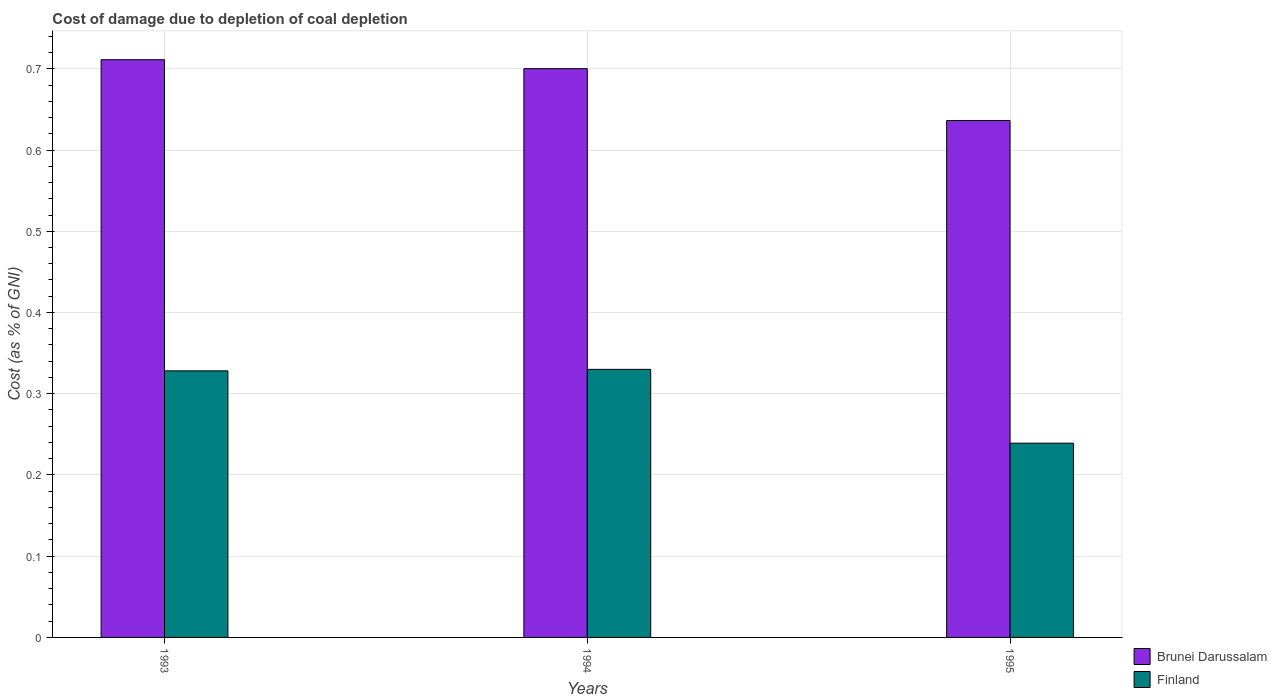How many groups of bars are there?
Ensure brevity in your answer.  3. Are the number of bars per tick equal to the number of legend labels?
Your answer should be very brief. Yes. Are the number of bars on each tick of the X-axis equal?
Provide a short and direct response. Yes. What is the label of the 1st group of bars from the left?
Give a very brief answer. 1993. In how many cases, is the number of bars for a given year not equal to the number of legend labels?
Your answer should be very brief. 0. What is the cost of damage caused due to coal depletion in Finland in 1995?
Make the answer very short. 0.24. Across all years, what is the maximum cost of damage caused due to coal depletion in Brunei Darussalam?
Offer a terse response. 0.71. Across all years, what is the minimum cost of damage caused due to coal depletion in Finland?
Keep it short and to the point. 0.24. What is the total cost of damage caused due to coal depletion in Finland in the graph?
Make the answer very short. 0.9. What is the difference between the cost of damage caused due to coal depletion in Brunei Darussalam in 1993 and that in 1994?
Offer a very short reply. 0.01. What is the difference between the cost of damage caused due to coal depletion in Finland in 1994 and the cost of damage caused due to coal depletion in Brunei Darussalam in 1995?
Your response must be concise. -0.31. What is the average cost of damage caused due to coal depletion in Finland per year?
Offer a terse response. 0.3. In the year 1995, what is the difference between the cost of damage caused due to coal depletion in Finland and cost of damage caused due to coal depletion in Brunei Darussalam?
Offer a terse response. -0.4. What is the ratio of the cost of damage caused due to coal depletion in Brunei Darussalam in 1993 to that in 1995?
Ensure brevity in your answer.  1.12. Is the cost of damage caused due to coal depletion in Brunei Darussalam in 1993 less than that in 1994?
Keep it short and to the point. No. What is the difference between the highest and the second highest cost of damage caused due to coal depletion in Brunei Darussalam?
Keep it short and to the point. 0.01. What is the difference between the highest and the lowest cost of damage caused due to coal depletion in Brunei Darussalam?
Make the answer very short. 0.07. In how many years, is the cost of damage caused due to coal depletion in Brunei Darussalam greater than the average cost of damage caused due to coal depletion in Brunei Darussalam taken over all years?
Your response must be concise. 2. Is the sum of the cost of damage caused due to coal depletion in Brunei Darussalam in 1993 and 1995 greater than the maximum cost of damage caused due to coal depletion in Finland across all years?
Give a very brief answer. Yes. How many bars are there?
Provide a succinct answer. 6. Are all the bars in the graph horizontal?
Your answer should be very brief. No. How many years are there in the graph?
Offer a terse response. 3. Where does the legend appear in the graph?
Offer a very short reply. Bottom right. How many legend labels are there?
Ensure brevity in your answer.  2. What is the title of the graph?
Provide a succinct answer. Cost of damage due to depletion of coal depletion. Does "Curacao" appear as one of the legend labels in the graph?
Your response must be concise. No. What is the label or title of the Y-axis?
Ensure brevity in your answer.  Cost (as % of GNI). What is the Cost (as % of GNI) in Brunei Darussalam in 1993?
Provide a short and direct response. 0.71. What is the Cost (as % of GNI) of Finland in 1993?
Keep it short and to the point. 0.33. What is the Cost (as % of GNI) of Brunei Darussalam in 1994?
Make the answer very short. 0.7. What is the Cost (as % of GNI) in Finland in 1994?
Provide a succinct answer. 0.33. What is the Cost (as % of GNI) of Brunei Darussalam in 1995?
Give a very brief answer. 0.64. What is the Cost (as % of GNI) in Finland in 1995?
Your response must be concise. 0.24. Across all years, what is the maximum Cost (as % of GNI) in Brunei Darussalam?
Offer a very short reply. 0.71. Across all years, what is the maximum Cost (as % of GNI) in Finland?
Keep it short and to the point. 0.33. Across all years, what is the minimum Cost (as % of GNI) in Brunei Darussalam?
Provide a short and direct response. 0.64. Across all years, what is the minimum Cost (as % of GNI) in Finland?
Make the answer very short. 0.24. What is the total Cost (as % of GNI) in Brunei Darussalam in the graph?
Your answer should be compact. 2.05. What is the total Cost (as % of GNI) of Finland in the graph?
Offer a terse response. 0.9. What is the difference between the Cost (as % of GNI) in Brunei Darussalam in 1993 and that in 1994?
Give a very brief answer. 0.01. What is the difference between the Cost (as % of GNI) in Finland in 1993 and that in 1994?
Offer a terse response. -0. What is the difference between the Cost (as % of GNI) in Brunei Darussalam in 1993 and that in 1995?
Offer a terse response. 0.07. What is the difference between the Cost (as % of GNI) of Finland in 1993 and that in 1995?
Your answer should be very brief. 0.09. What is the difference between the Cost (as % of GNI) in Brunei Darussalam in 1994 and that in 1995?
Keep it short and to the point. 0.06. What is the difference between the Cost (as % of GNI) in Finland in 1994 and that in 1995?
Offer a very short reply. 0.09. What is the difference between the Cost (as % of GNI) in Brunei Darussalam in 1993 and the Cost (as % of GNI) in Finland in 1994?
Keep it short and to the point. 0.38. What is the difference between the Cost (as % of GNI) of Brunei Darussalam in 1993 and the Cost (as % of GNI) of Finland in 1995?
Offer a terse response. 0.47. What is the difference between the Cost (as % of GNI) in Brunei Darussalam in 1994 and the Cost (as % of GNI) in Finland in 1995?
Provide a short and direct response. 0.46. What is the average Cost (as % of GNI) in Brunei Darussalam per year?
Make the answer very short. 0.68. What is the average Cost (as % of GNI) of Finland per year?
Your response must be concise. 0.3. In the year 1993, what is the difference between the Cost (as % of GNI) in Brunei Darussalam and Cost (as % of GNI) in Finland?
Provide a succinct answer. 0.38. In the year 1994, what is the difference between the Cost (as % of GNI) of Brunei Darussalam and Cost (as % of GNI) of Finland?
Your response must be concise. 0.37. In the year 1995, what is the difference between the Cost (as % of GNI) in Brunei Darussalam and Cost (as % of GNI) in Finland?
Offer a very short reply. 0.4. What is the ratio of the Cost (as % of GNI) in Brunei Darussalam in 1993 to that in 1994?
Your answer should be very brief. 1.02. What is the ratio of the Cost (as % of GNI) in Finland in 1993 to that in 1994?
Keep it short and to the point. 0.99. What is the ratio of the Cost (as % of GNI) of Brunei Darussalam in 1993 to that in 1995?
Your response must be concise. 1.12. What is the ratio of the Cost (as % of GNI) of Finland in 1993 to that in 1995?
Your answer should be compact. 1.37. What is the ratio of the Cost (as % of GNI) in Brunei Darussalam in 1994 to that in 1995?
Keep it short and to the point. 1.1. What is the ratio of the Cost (as % of GNI) of Finland in 1994 to that in 1995?
Provide a succinct answer. 1.38. What is the difference between the highest and the second highest Cost (as % of GNI) of Brunei Darussalam?
Ensure brevity in your answer.  0.01. What is the difference between the highest and the second highest Cost (as % of GNI) of Finland?
Keep it short and to the point. 0. What is the difference between the highest and the lowest Cost (as % of GNI) in Brunei Darussalam?
Provide a succinct answer. 0.07. What is the difference between the highest and the lowest Cost (as % of GNI) in Finland?
Offer a terse response. 0.09. 